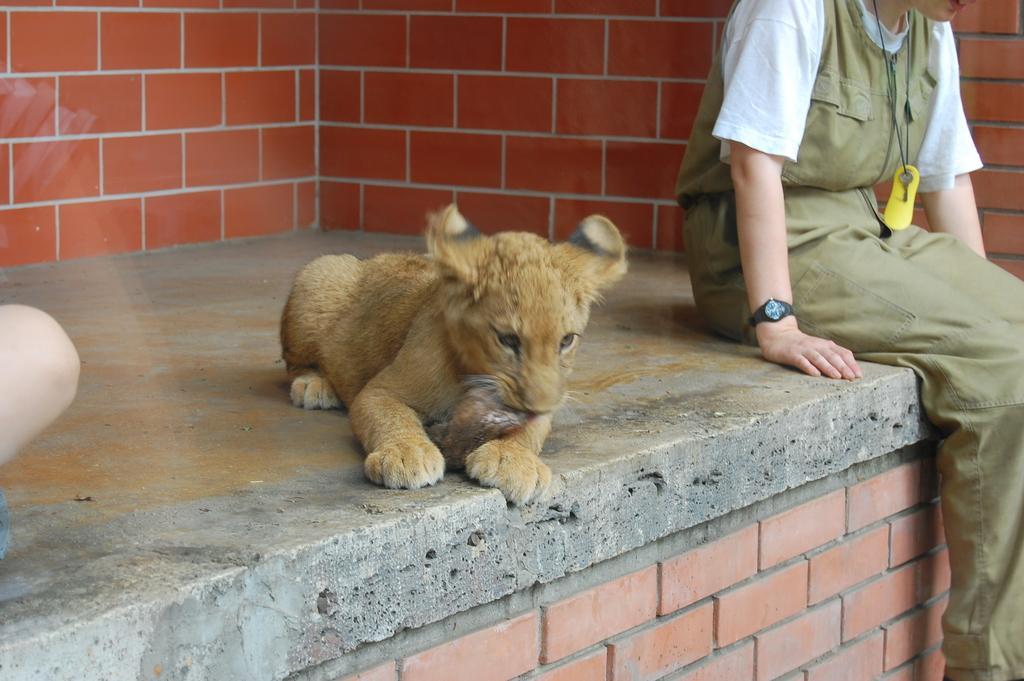Please provide a concise description of this image. In this image in the center there is an animal sitting on the floor and there is a person sitting. In the background there is a wall which is red in colour. On the left side there is an object which is brown in colour. 